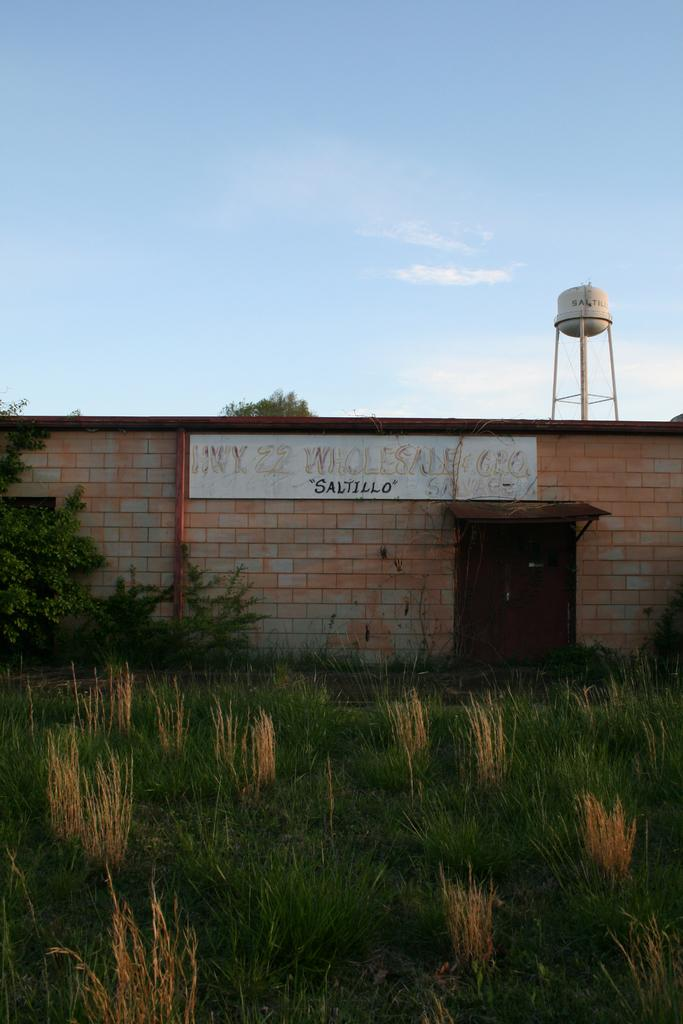What type of ground surface is visible at the bottom of the image? There is grass at the bottom of the image. What can be seen in the background of the image? There is a wall in the background. What type of structure is present in the image? There is a door in the image. What is the large, cylindrical object in the image? There is a water tank in the image. What is visible at the top of the image? The sky is visible at the top of the image. How many trays are stacked on the water tank in the image? There are no trays present in the image. What level of comfort does the grass provide in the image? The image does not convey any information about the comfort level of the grass. 